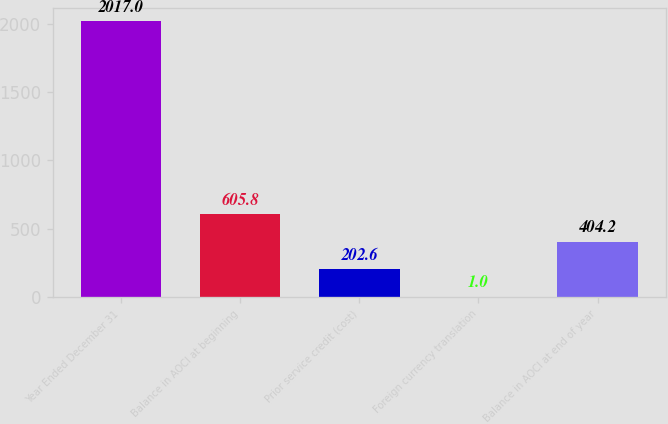<chart> <loc_0><loc_0><loc_500><loc_500><bar_chart><fcel>Year Ended December 31<fcel>Balance in AOCI at beginning<fcel>Prior service credit (cost)<fcel>Foreign currency translation<fcel>Balance in AOCI at end of year<nl><fcel>2017<fcel>605.8<fcel>202.6<fcel>1<fcel>404.2<nl></chart> 